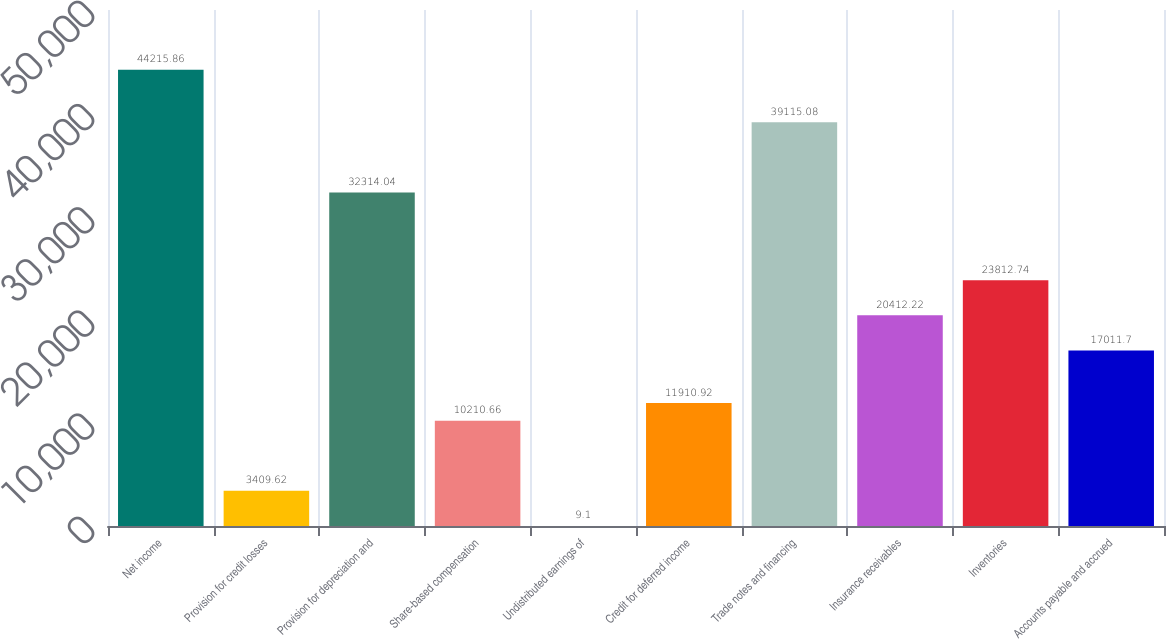Convert chart. <chart><loc_0><loc_0><loc_500><loc_500><bar_chart><fcel>Net income<fcel>Provision for credit losses<fcel>Provision for depreciation and<fcel>Share-based compensation<fcel>Undistributed earnings of<fcel>Credit for deferred income<fcel>Trade notes and financing<fcel>Insurance receivables<fcel>Inventories<fcel>Accounts payable and accrued<nl><fcel>44215.9<fcel>3409.62<fcel>32314<fcel>10210.7<fcel>9.1<fcel>11910.9<fcel>39115.1<fcel>20412.2<fcel>23812.7<fcel>17011.7<nl></chart> 